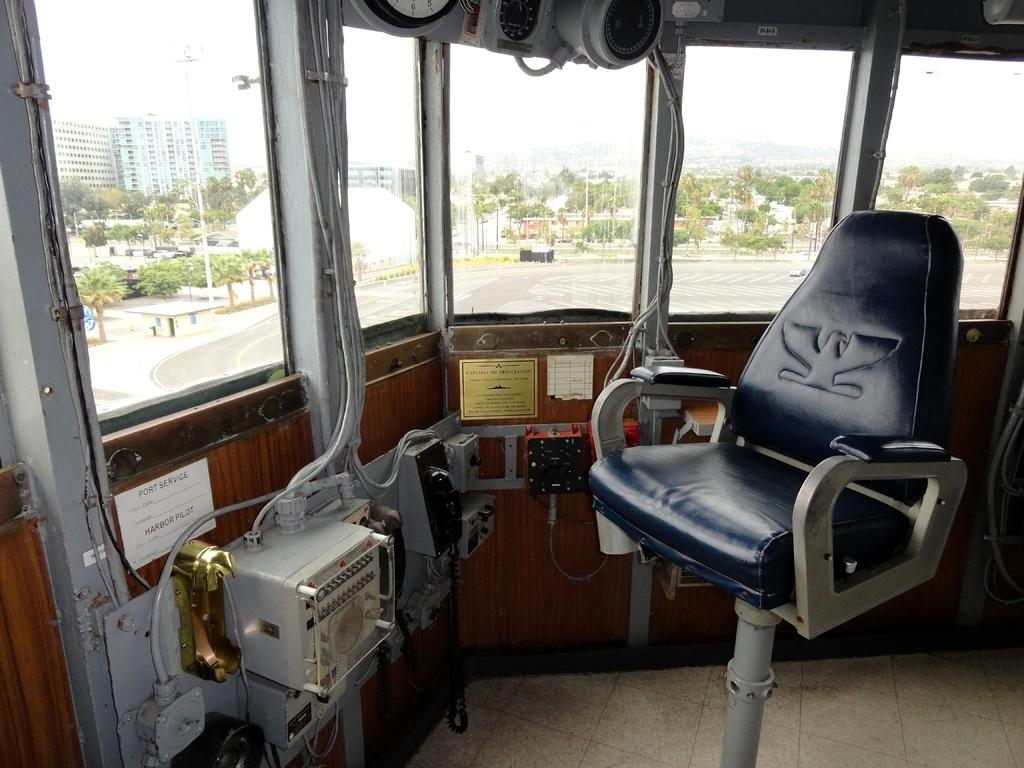What is located in the middle of the picture? There is a chair in the middle of the picture. What type of equipment can be seen in the picture? There is machinery equipment in the picture. What can be seen through the windows in the picture? The windows provide a view of the road, trees, poles, buildings, and the sky. Where is the daughter sitting in the lunchroom in the image? There is no lunchroom or daughter present in the image. What type of twig can be seen growing from the machinery equipment in the image? There are no twigs visible in the image, and the machinery equipment is not associated with plant growth. 